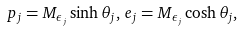<formula> <loc_0><loc_0><loc_500><loc_500>p _ { j } = M _ { \epsilon _ { j } } \sinh \theta _ { j } , \, e _ { j } = M _ { \epsilon _ { j } } \cosh \theta _ { j } ,</formula> 